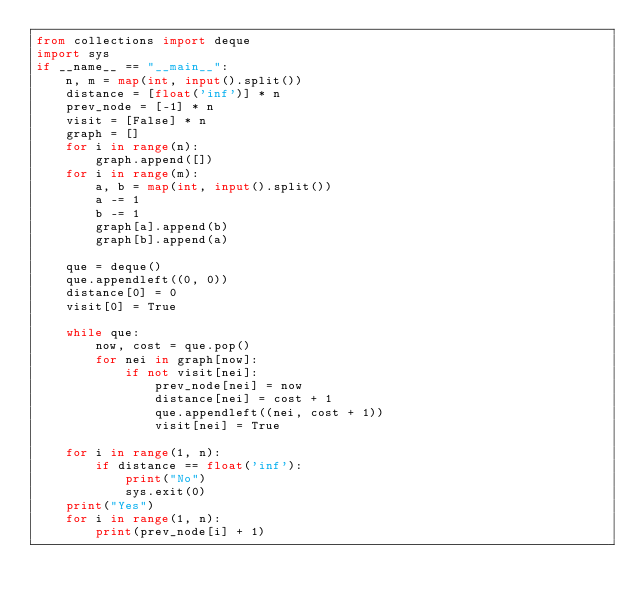Convert code to text. <code><loc_0><loc_0><loc_500><loc_500><_Python_>from collections import deque
import sys
if __name__ == "__main__":
    n, m = map(int, input().split())
    distance = [float('inf')] * n
    prev_node = [-1] * n
    visit = [False] * n
    graph = []
    for i in range(n):
        graph.append([])
    for i in range(m):
        a, b = map(int, input().split())
        a -= 1
        b -= 1
        graph[a].append(b)
        graph[b].append(a)
    
    que = deque()
    que.appendleft((0, 0))
    distance[0] = 0
    visit[0] = True

    while que:
        now, cost = que.pop()
        for nei in graph[now]:
            if not visit[nei]:
                prev_node[nei] = now
                distance[nei] = cost + 1
                que.appendleft((nei, cost + 1))
                visit[nei] = True

    for i in range(1, n):
        if distance == float('inf'):
            print("No")
            sys.exit(0)
    print("Yes")
    for i in range(1, n):
        print(prev_node[i] + 1)</code> 